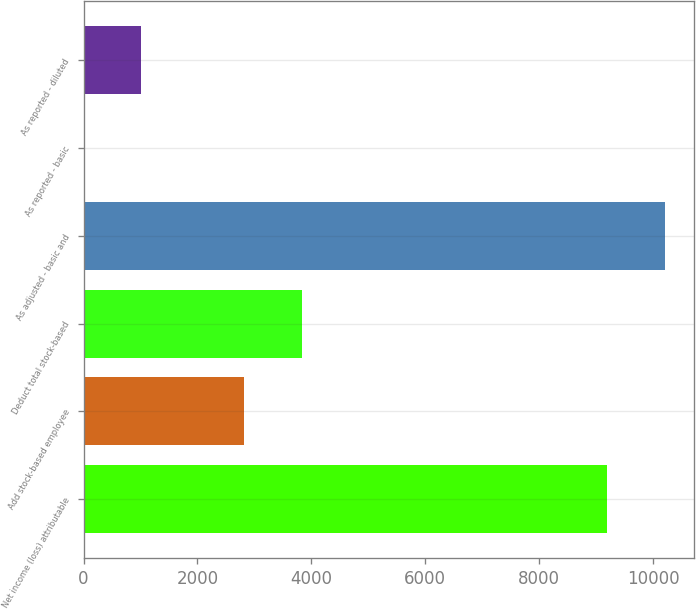<chart> <loc_0><loc_0><loc_500><loc_500><bar_chart><fcel>Net income (loss) attributable<fcel>Add stock-based employee<fcel>Deduct total stock-based<fcel>As adjusted - basic and<fcel>As reported - basic<fcel>As reported - diluted<nl><fcel>9194<fcel>2826<fcel>3842.99<fcel>10211<fcel>0.08<fcel>1017.07<nl></chart> 